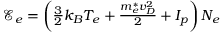Convert formula to latex. <formula><loc_0><loc_0><loc_500><loc_500>\begin{array} { r } { \mathcal { E } _ { e } = \left ( \frac { 3 } { 2 } k _ { B } { T _ { e } } + \frac { m _ { e } ^ { * } { v _ { D } ^ { 2 } } } { 2 } + I _ { p } \right ) { N _ { e } } } \end{array}</formula> 